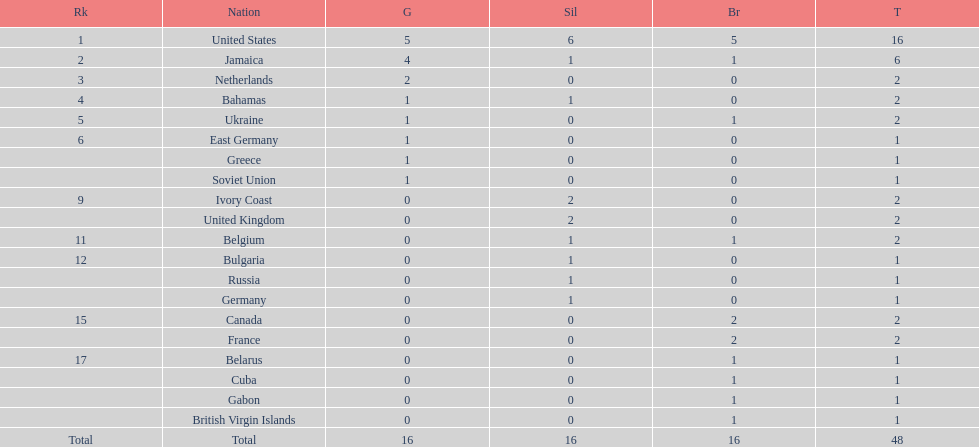What country won the most silver medals? United States. 